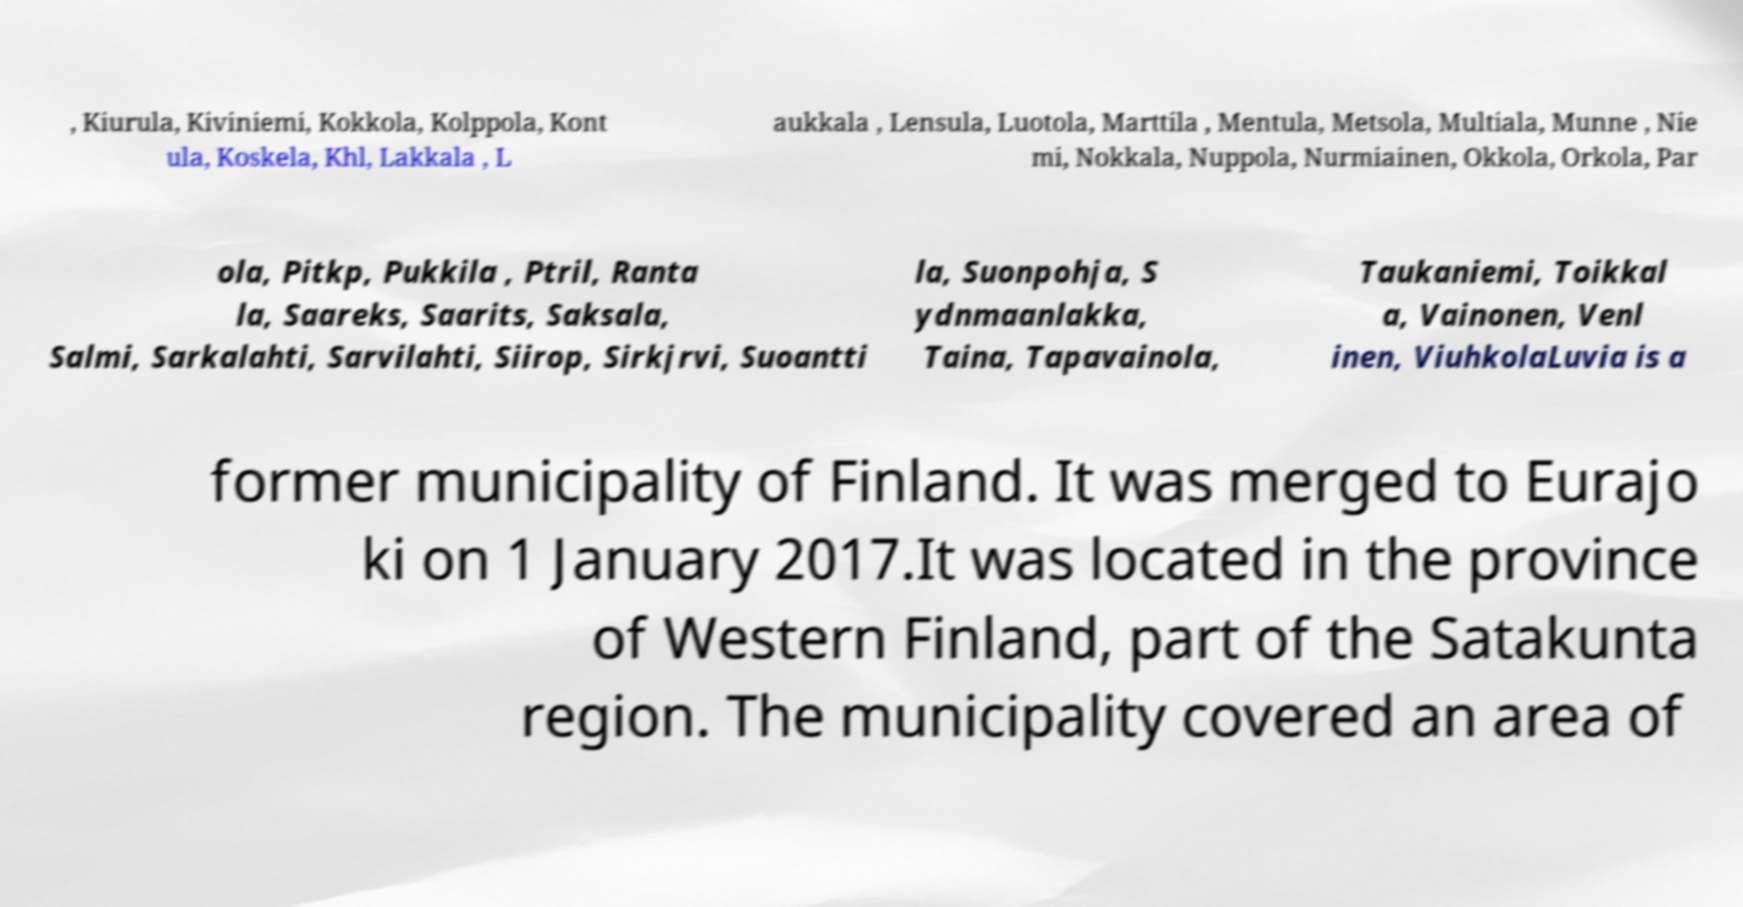Can you read and provide the text displayed in the image?This photo seems to have some interesting text. Can you extract and type it out for me? , Kiurula, Kiviniemi, Kokkola, Kolppola, Kont ula, Koskela, Khl, Lakkala , L aukkala , Lensula, Luotola, Marttila , Mentula, Metsola, Multiala, Munne , Nie mi, Nokkala, Nuppola, Nurmiainen, Okkola, Orkola, Par ola, Pitkp, Pukkila , Ptril, Ranta la, Saareks, Saarits, Saksala, Salmi, Sarkalahti, Sarvilahti, Siirop, Sirkjrvi, Suoantti la, Suonpohja, S ydnmaanlakka, Taina, Tapavainola, Taukaniemi, Toikkal a, Vainonen, Venl inen, ViuhkolaLuvia is a former municipality of Finland. It was merged to Eurajo ki on 1 January 2017.It was located in the province of Western Finland, part of the Satakunta region. The municipality covered an area of 